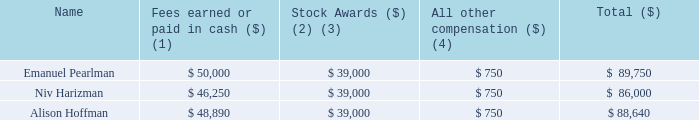Director Compensation
In 2019, we compensated each non-management director of our Company by granting to each such outside director 15,000 RSUs. The RSUs vested in equal amounts of 3,750 RSUs on each of March 15, 2019, June 15, 2019, September 15, 2019 and December 15, 2019. In addition, we pay our non-management directors cash director fees of $40,000 per annum ($10,000 per quarter). Non-management directors also receive additional cash compensation on an annual basis for serving on the following Board committees: The Audit Committee Chairperson receives $7,500 and members receive $5,000; the Chairperson and members of each of the Compensation Committee and Nominating and Corporate Governance Committee receive annual fees of $3,750 and $2,500, respectively.
In consideration for serving as the sole member of our Strategic Development Committee, in June 2013 we issued to Niv Harizman a five-year stock option to purchase 300,000 shares of our common stock, at an exercise price of $1.88 per share, which option vested 100,000 shares on the date of grant, 100,000 shares on the first anniversary of the date of grant and vested 100,000 shares on the second anniversary from the grant date. On June 17, 2018, Mr. Harizman exercised the aforementioned stock option on a net (cashless) exercise basis by delivering to us 181,936 shares of our common stock and he received 118,064 shares of our common stock.
The following table sets forth the compensation awarded to, earned by or paid to all persons who served as members of our board of directors (other than our Named Executive Officers) during the year ended December 31, 2019. No director who is also a Named Executive Officer received any compensation for services as a director in 2019.
(1) Represents directors’ fees payable in cash to each non-management director of $10,000 per quarter ($40,000 per annum) for 2019 plus additional cash fees for serving on Board committees as disclosed in the text above.
(2) The amounts included in this column represent the grant date fair value of restricted stock unit awards (RSUs) granted to directors, computed in accordance with FASB ASC Topic 718. For a discussion of valuation assumptions see Note B[11] to our consolidated financial statements included in this Annual Report. The 15,000 RSUs granted to each non-management director vested on a quarterly basis beginning March 15, 2019. Each restricted stock unit represents the contingent right to receive one share of common stock.
(3) As of December 31, 2019, each of the above listed directors held outstanding stock options to purchase 35,000 shares of our common stock at an exercise price of $2.34 per share.
(4) Includes payment of dividends (dividend equivalent rights) on RSUs for 2019.
What does Note B[11] detail? Discussion of valuation assumptions. Who are the members who served as members of the board of directors (other than Named Executive Officers)? Emanuel pearlman, niv harizman, alison hoffman. How much are the directors’ fees payable in cash to each non-management director, per quarter for 2019? $10,000. Which director was compensated the most in 2019? 89,750>88,640>86,000
Answer: emanuel pearlman. What was the total amount of money received by one audit committee chairperson and one member? 7,500+5,000
Answer: 12500. How many directors received compensation of more than $88,000? Emanuel Pearlman##Alison Hoffman
Answer: 2. 